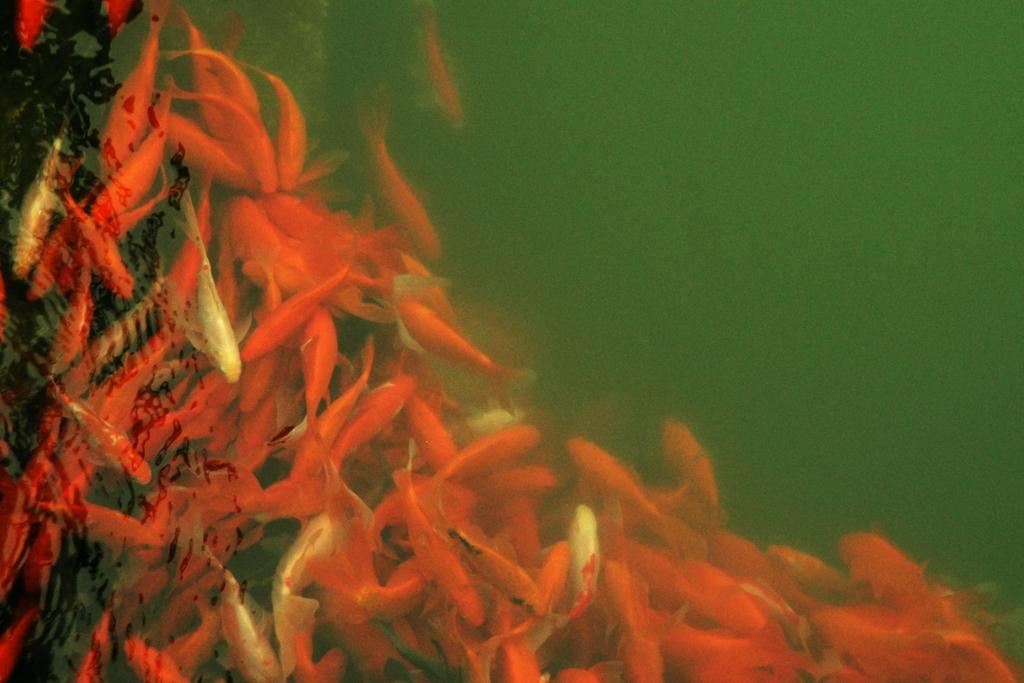What type of animals can be seen in the water in the image? There are orange fishes in the water. Can you describe the color of the fishes? The fishes are orange in color. What is the primary element in which the fishes are situated? The fishes are situated in water. What type of clocks can be seen in the image? There are no clocks present in the image; it features orange fishes in the water. 